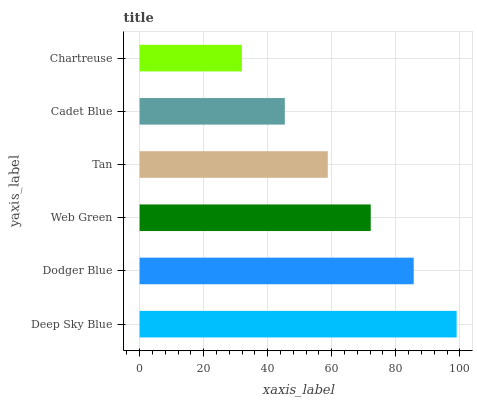Is Chartreuse the minimum?
Answer yes or no. Yes. Is Deep Sky Blue the maximum?
Answer yes or no. Yes. Is Dodger Blue the minimum?
Answer yes or no. No. Is Dodger Blue the maximum?
Answer yes or no. No. Is Deep Sky Blue greater than Dodger Blue?
Answer yes or no. Yes. Is Dodger Blue less than Deep Sky Blue?
Answer yes or no. Yes. Is Dodger Blue greater than Deep Sky Blue?
Answer yes or no. No. Is Deep Sky Blue less than Dodger Blue?
Answer yes or no. No. Is Web Green the high median?
Answer yes or no. Yes. Is Tan the low median?
Answer yes or no. Yes. Is Tan the high median?
Answer yes or no. No. Is Web Green the low median?
Answer yes or no. No. 